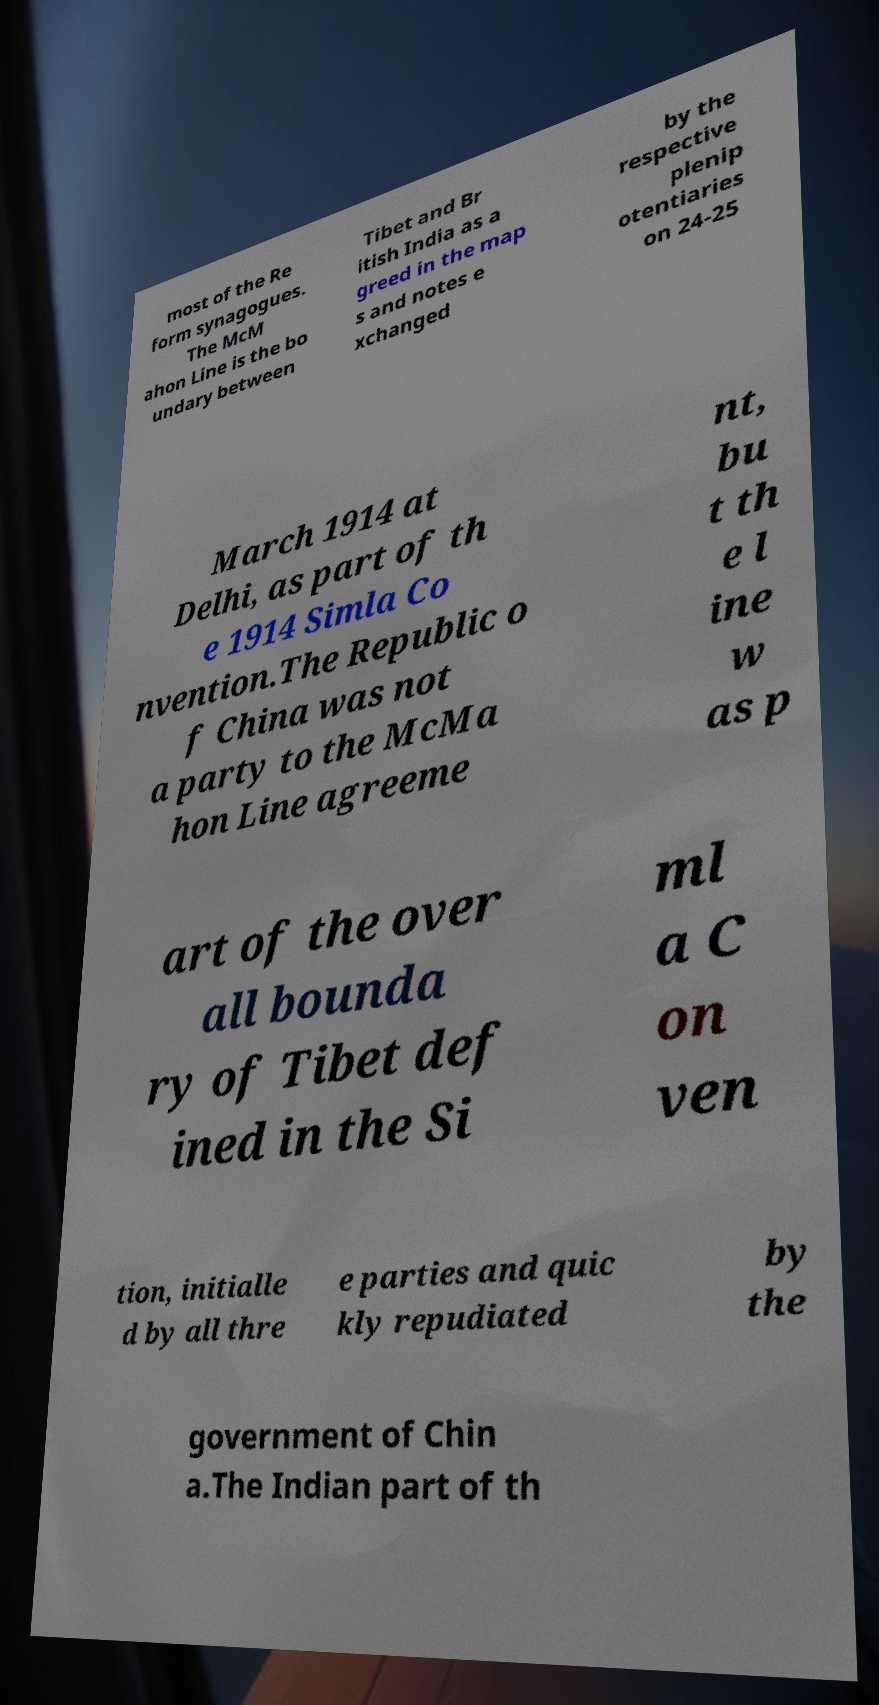For documentation purposes, I need the text within this image transcribed. Could you provide that? most of the Re form synagogues. The McM ahon Line is the bo undary between Tibet and Br itish India as a greed in the map s and notes e xchanged by the respective plenip otentiaries on 24-25 March 1914 at Delhi, as part of th e 1914 Simla Co nvention.The Republic o f China was not a party to the McMa hon Line agreeme nt, bu t th e l ine w as p art of the over all bounda ry of Tibet def ined in the Si ml a C on ven tion, initialle d by all thre e parties and quic kly repudiated by the government of Chin a.The Indian part of th 